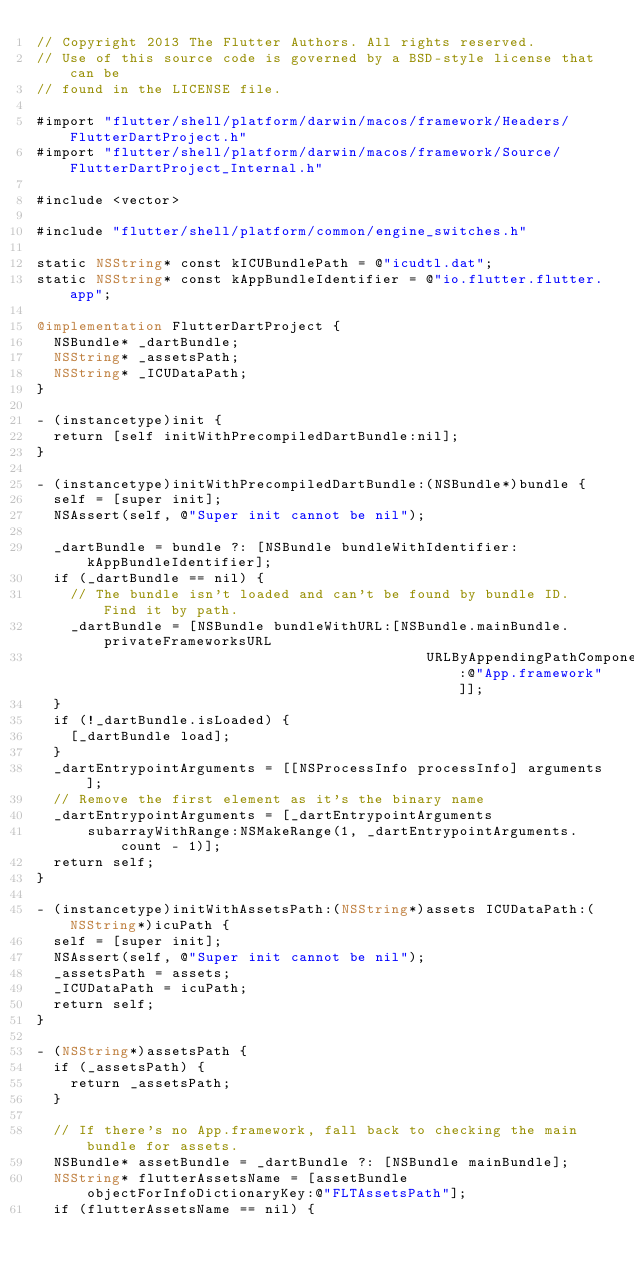Convert code to text. <code><loc_0><loc_0><loc_500><loc_500><_ObjectiveC_>// Copyright 2013 The Flutter Authors. All rights reserved.
// Use of this source code is governed by a BSD-style license that can be
// found in the LICENSE file.

#import "flutter/shell/platform/darwin/macos/framework/Headers/FlutterDartProject.h"
#import "flutter/shell/platform/darwin/macos/framework/Source/FlutterDartProject_Internal.h"

#include <vector>

#include "flutter/shell/platform/common/engine_switches.h"

static NSString* const kICUBundlePath = @"icudtl.dat";
static NSString* const kAppBundleIdentifier = @"io.flutter.flutter.app";

@implementation FlutterDartProject {
  NSBundle* _dartBundle;
  NSString* _assetsPath;
  NSString* _ICUDataPath;
}

- (instancetype)init {
  return [self initWithPrecompiledDartBundle:nil];
}

- (instancetype)initWithPrecompiledDartBundle:(NSBundle*)bundle {
  self = [super init];
  NSAssert(self, @"Super init cannot be nil");

  _dartBundle = bundle ?: [NSBundle bundleWithIdentifier:kAppBundleIdentifier];
  if (_dartBundle == nil) {
    // The bundle isn't loaded and can't be found by bundle ID. Find it by path.
    _dartBundle = [NSBundle bundleWithURL:[NSBundle.mainBundle.privateFrameworksURL
                                              URLByAppendingPathComponent:@"App.framework"]];
  }
  if (!_dartBundle.isLoaded) {
    [_dartBundle load];
  }
  _dartEntrypointArguments = [[NSProcessInfo processInfo] arguments];
  // Remove the first element as it's the binary name
  _dartEntrypointArguments = [_dartEntrypointArguments
      subarrayWithRange:NSMakeRange(1, _dartEntrypointArguments.count - 1)];
  return self;
}

- (instancetype)initWithAssetsPath:(NSString*)assets ICUDataPath:(NSString*)icuPath {
  self = [super init];
  NSAssert(self, @"Super init cannot be nil");
  _assetsPath = assets;
  _ICUDataPath = icuPath;
  return self;
}

- (NSString*)assetsPath {
  if (_assetsPath) {
    return _assetsPath;
  }

  // If there's no App.framework, fall back to checking the main bundle for assets.
  NSBundle* assetBundle = _dartBundle ?: [NSBundle mainBundle];
  NSString* flutterAssetsName = [assetBundle objectForInfoDictionaryKey:@"FLTAssetsPath"];
  if (flutterAssetsName == nil) {</code> 